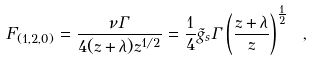Convert formula to latex. <formula><loc_0><loc_0><loc_500><loc_500>F _ { ( 1 , 2 , 0 ) } = \frac { \nu \Gamma } { 4 ( z + \lambda ) z ^ { 1 / 2 } } = \frac { 1 } { 4 } { \tilde { g } } _ { s } \Gamma \left ( \frac { z + \lambda } { z } \right ) ^ { \frac { 1 } { 2 } } \ , \label l { e q \colon t h r e e s t r i n g t w o }</formula> 